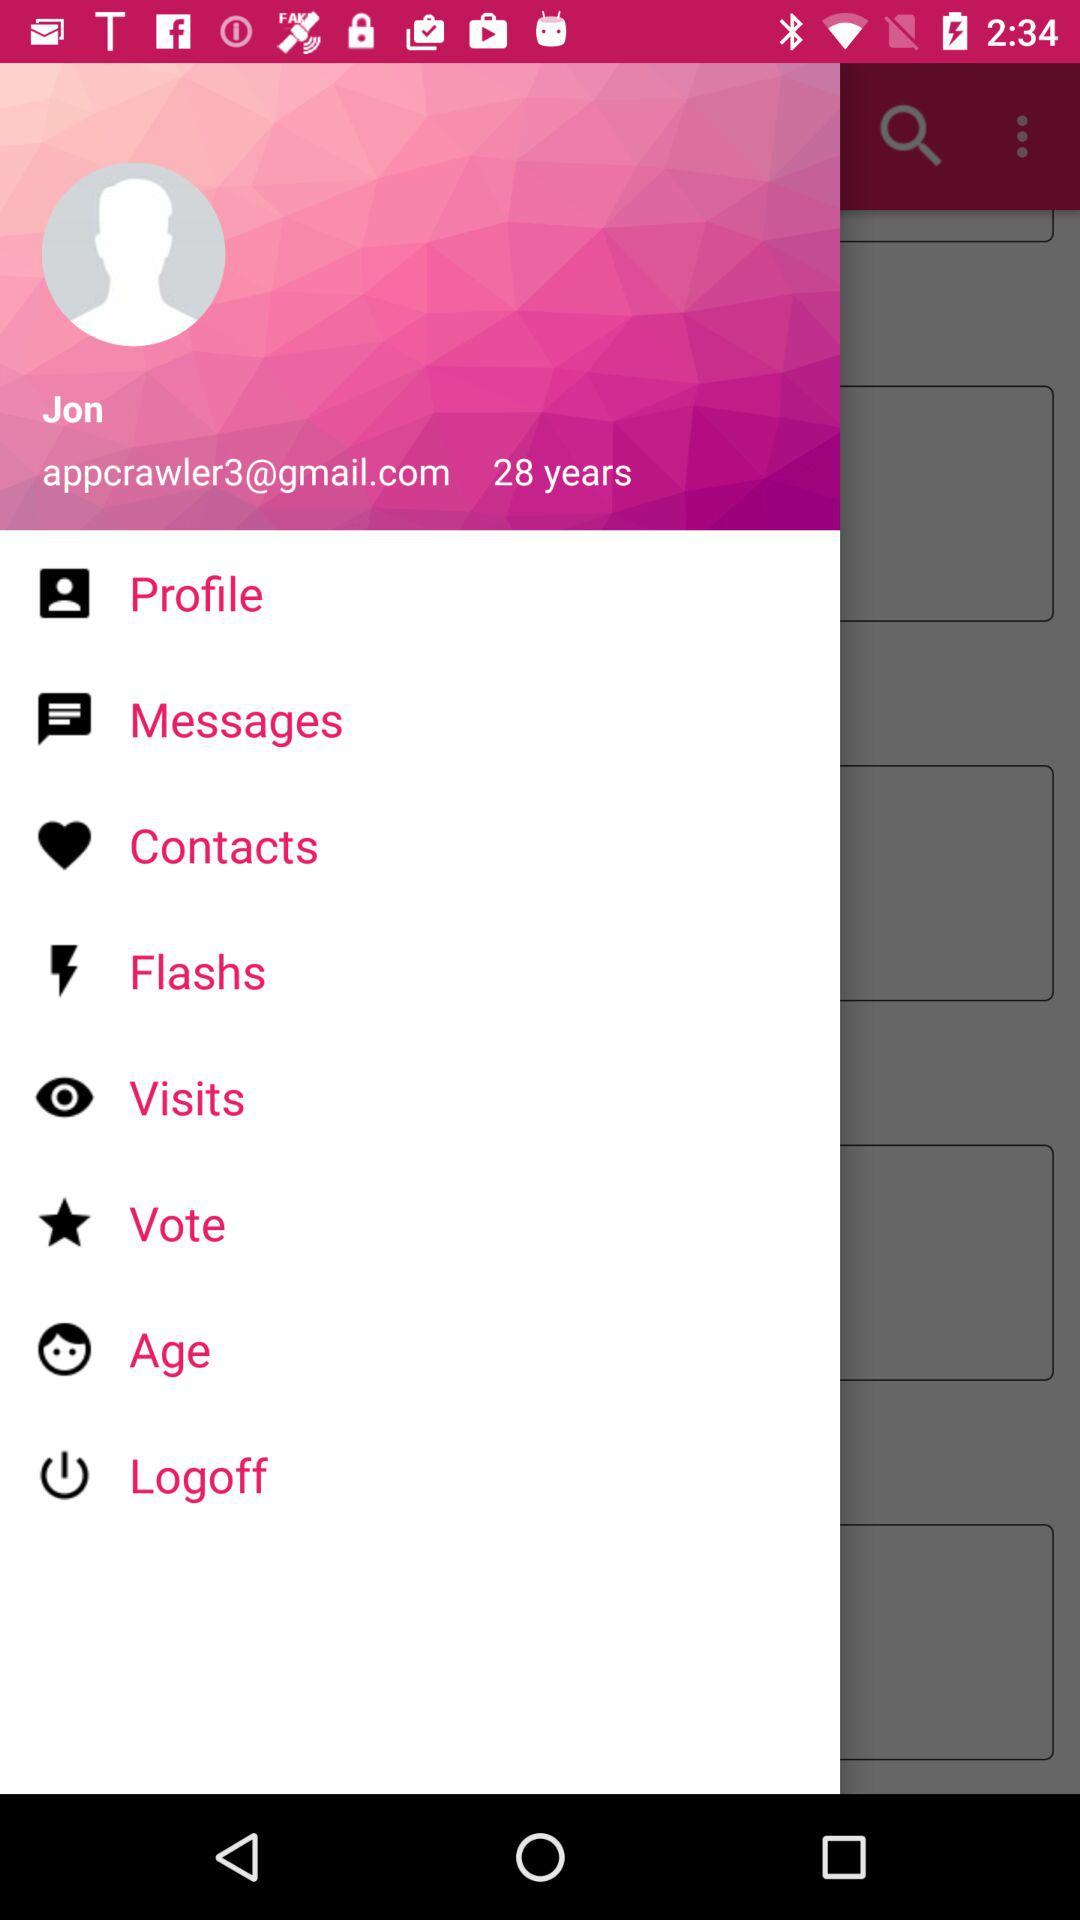What is the age? The age is 28 years. 